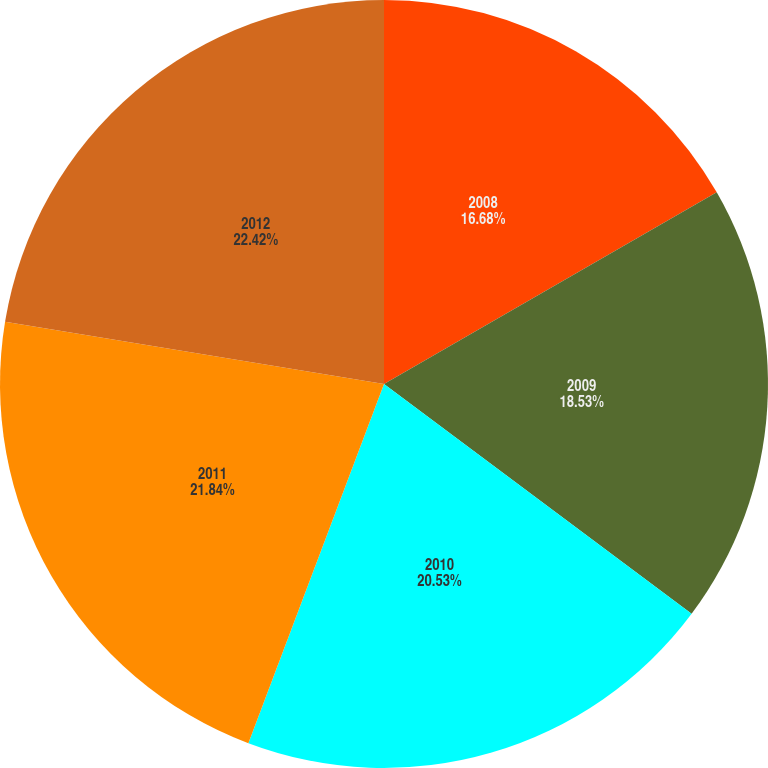Convert chart to OTSL. <chart><loc_0><loc_0><loc_500><loc_500><pie_chart><fcel>2008<fcel>2009<fcel>2010<fcel>2011<fcel>2012<nl><fcel>16.68%<fcel>18.53%<fcel>20.53%<fcel>21.84%<fcel>22.41%<nl></chart> 